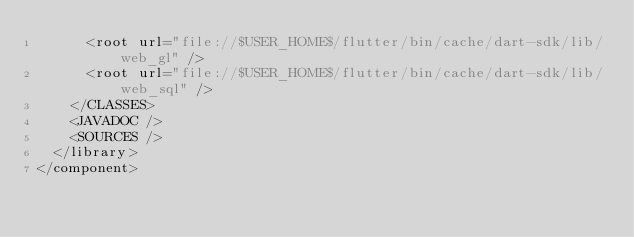Convert code to text. <code><loc_0><loc_0><loc_500><loc_500><_XML_>      <root url="file://$USER_HOME$/flutter/bin/cache/dart-sdk/lib/web_gl" />
      <root url="file://$USER_HOME$/flutter/bin/cache/dart-sdk/lib/web_sql" />
    </CLASSES>
    <JAVADOC />
    <SOURCES />
  </library>
</component></code> 